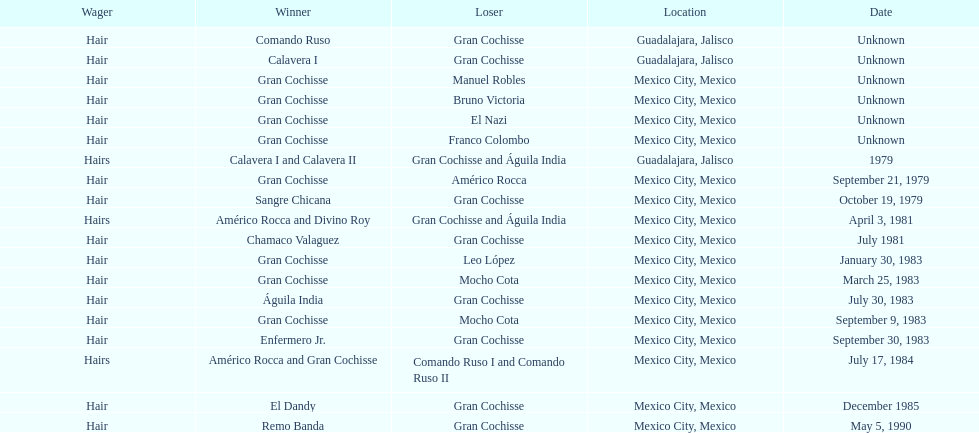When was the first match of gran chochisse with a fully recorded date held? September 21, 1979. 